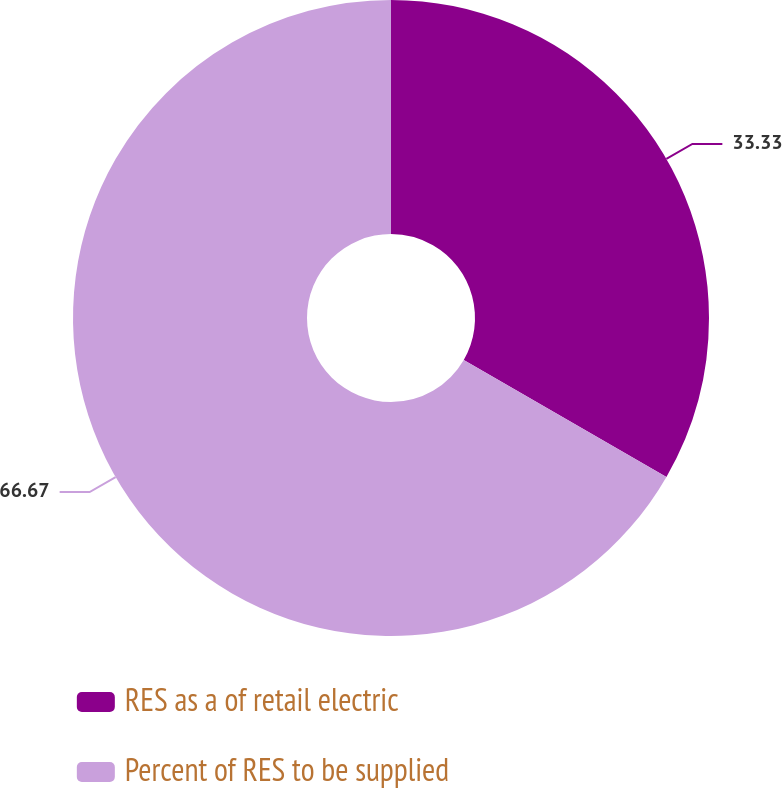<chart> <loc_0><loc_0><loc_500><loc_500><pie_chart><fcel>RES as a of retail electric<fcel>Percent of RES to be supplied<nl><fcel>33.33%<fcel>66.67%<nl></chart> 